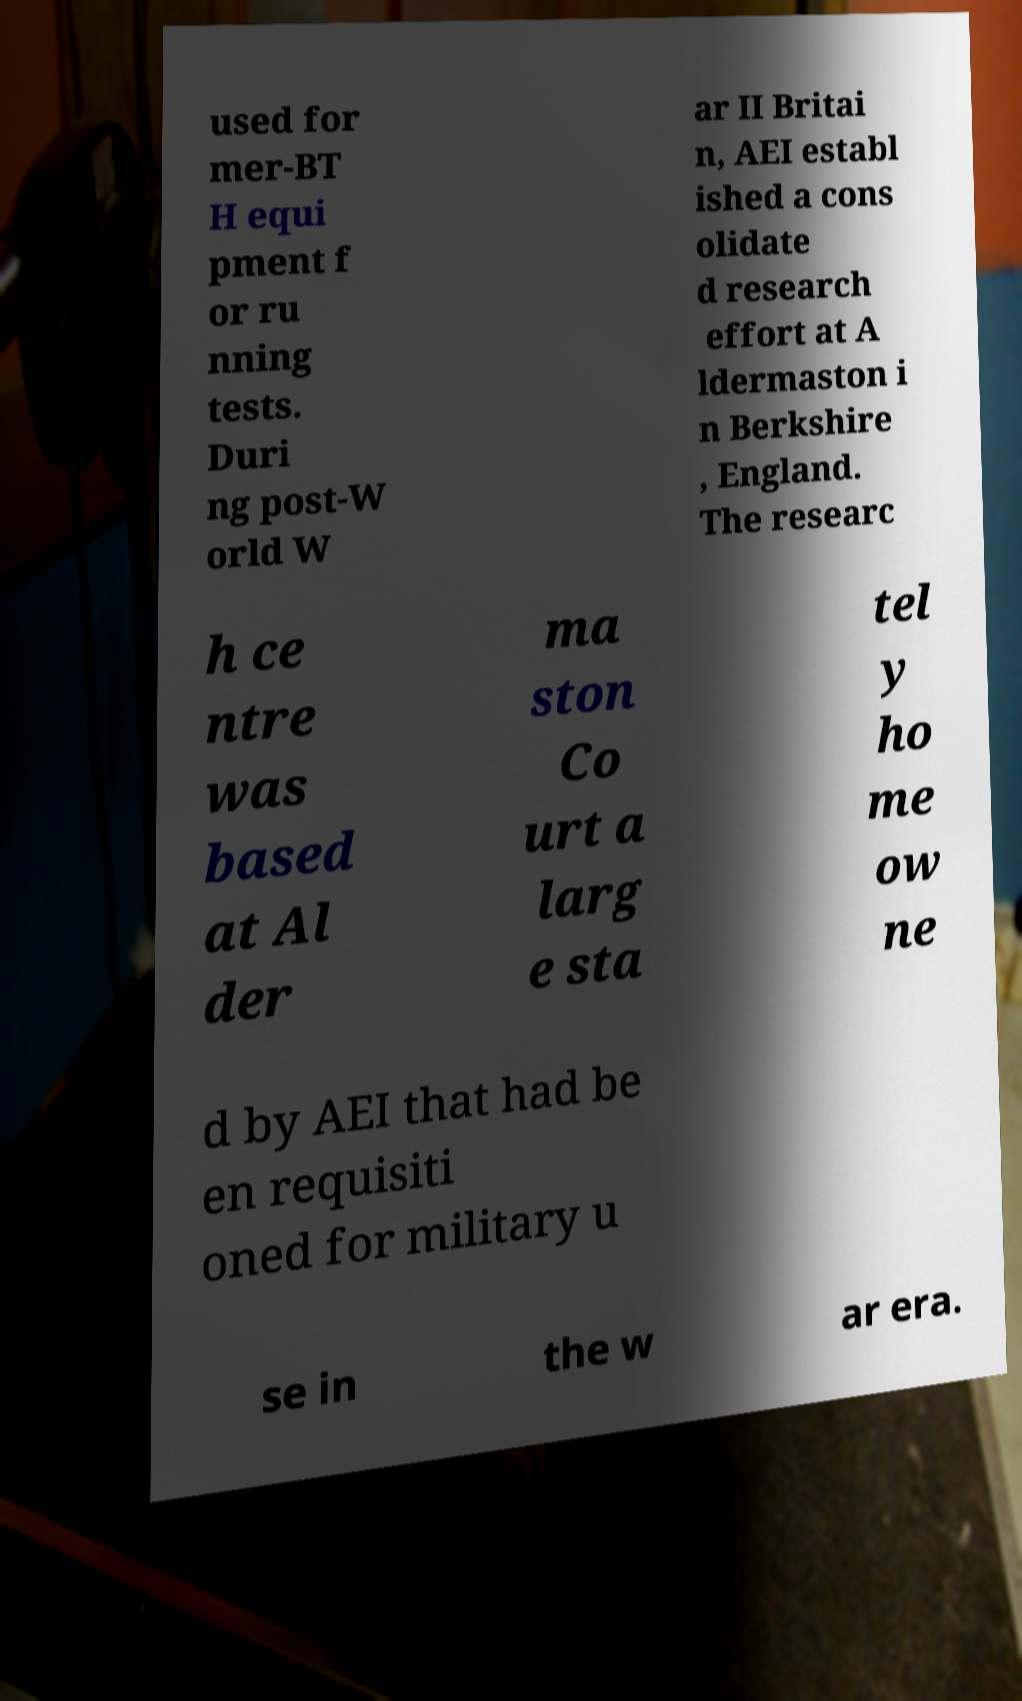Please identify and transcribe the text found in this image. used for mer-BT H equi pment f or ru nning tests. Duri ng post-W orld W ar II Britai n, AEI establ ished a cons olidate d research effort at A ldermaston i n Berkshire , England. The researc h ce ntre was based at Al der ma ston Co urt a larg e sta tel y ho me ow ne d by AEI that had be en requisiti oned for military u se in the w ar era. 